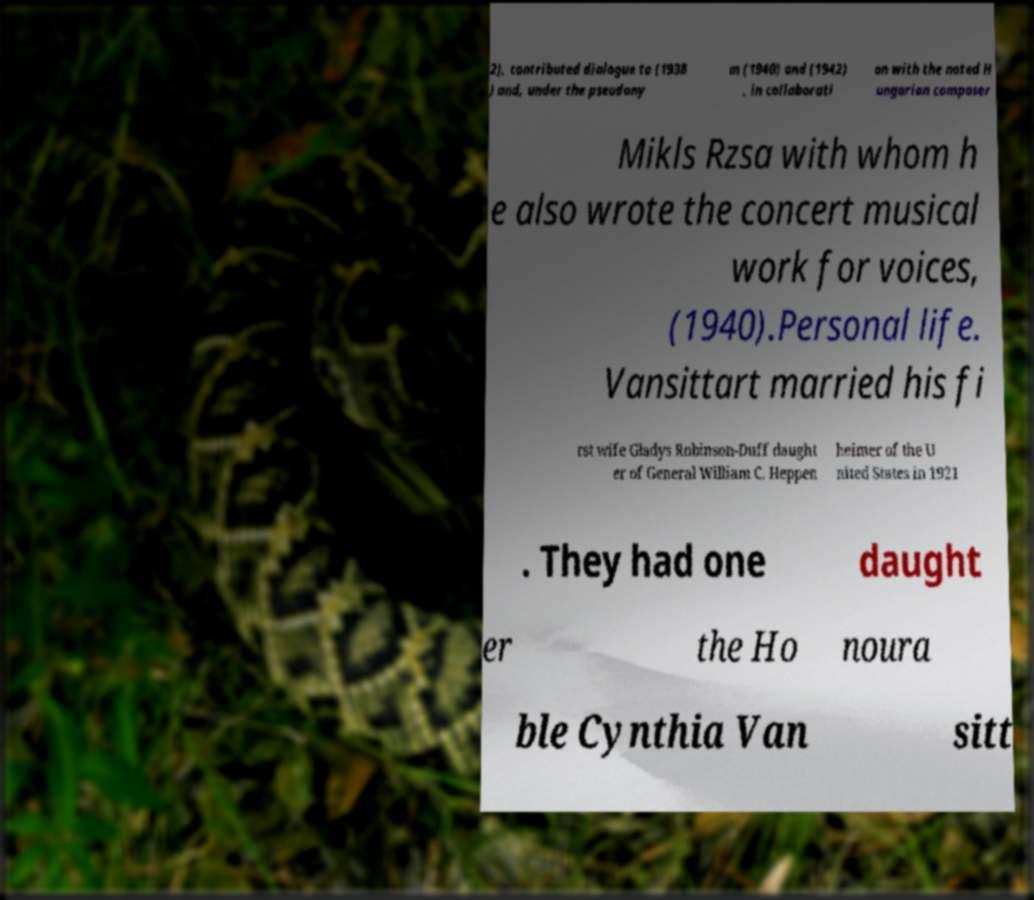Can you read and provide the text displayed in the image?This photo seems to have some interesting text. Can you extract and type it out for me? 2), contributed dialogue to (1938 ) and, under the pseudony m (1940) and (1942) , in collaborati on with the noted H ungarian composer Mikls Rzsa with whom h e also wrote the concert musical work for voices, (1940).Personal life. Vansittart married his fi rst wife Gladys Robinson-Duff daught er of General William C. Heppen heimer of the U nited States in 1921 . They had one daught er the Ho noura ble Cynthia Van sitt 